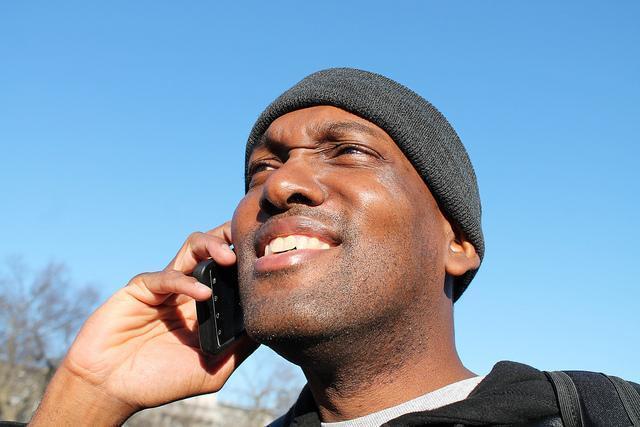How many sticks does the dog have in it's mouth?
Give a very brief answer. 0. 